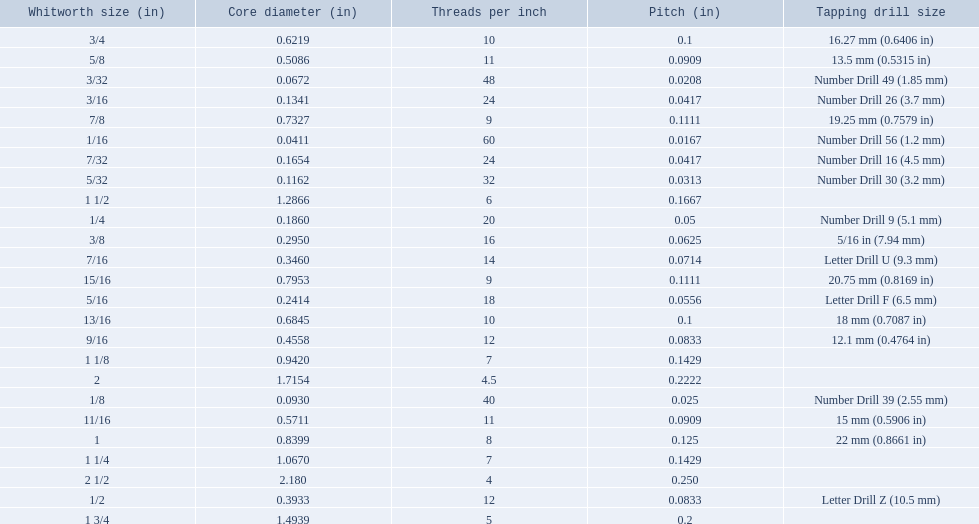What was the core diameter of a number drill 26 0.1341. What is this measurement in whitworth size? 3/16. 